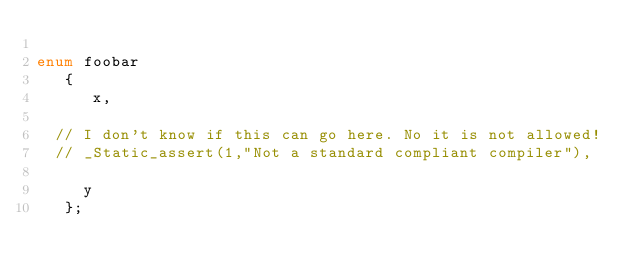Convert code to text. <code><loc_0><loc_0><loc_500><loc_500><_C_>
enum foobar
   {
      x,

  // I don't know if this can go here. No it is not allowed!
  // _Static_assert(1,"Not a standard compliant compiler"),

     y
   };


</code> 